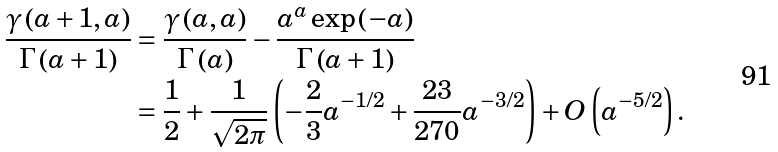<formula> <loc_0><loc_0><loc_500><loc_500>\frac { \gamma \left ( a + 1 , a \right ) } { \Gamma \left ( a + 1 \right ) } & = \frac { \gamma \left ( a , a \right ) } { \Gamma \left ( a \right ) } - \frac { a ^ { a } \exp \left ( - a \right ) } { \Gamma \left ( a + 1 \right ) } \\ & = \frac { 1 } { 2 } + \frac { 1 } { \sqrt { 2 \pi } } \left ( - \frac { 2 } { 3 } a ^ { - 1 / 2 } + \frac { 2 3 } { 2 7 0 } a ^ { - 3 / 2 } \right ) + O \left ( a ^ { - 5 / 2 } \right ) .</formula> 